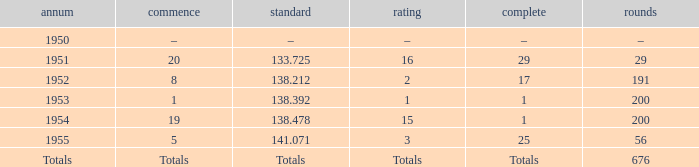How many laps was qualifier of 138.212? 191.0. 